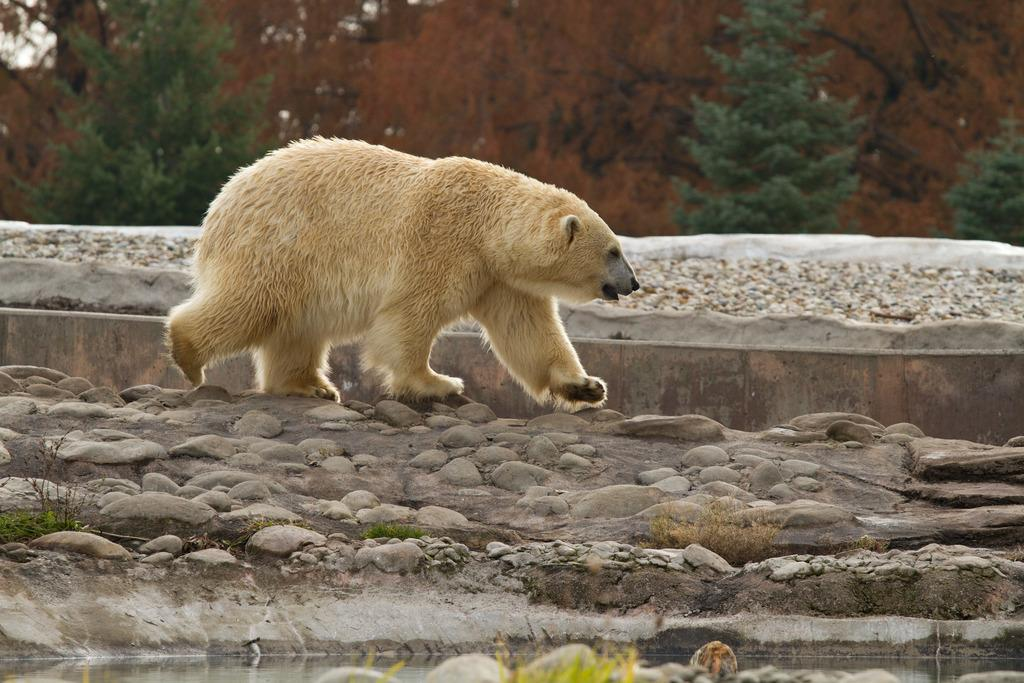What animal is present in the image? There is a polar bear in the image. What is the polar bear doing in the image? The polar bear is walking on the ground. What type of terrain can be seen in the image? There are stones on the ground. What can be seen in the background of the image? There are trees in the background of the image. What is visible at the bottom of the image? Water and stones are visible at the bottom of the image. Can you tell me how many babies are playing with plastic toys in the image? There are no babies or plastic toys present in the image; it features a polar bear walking on the ground. Is there a trail visible in the image? There is no trail visible in the image; it shows a polar bear walking on the ground with stones, trees, water, and more stones. 